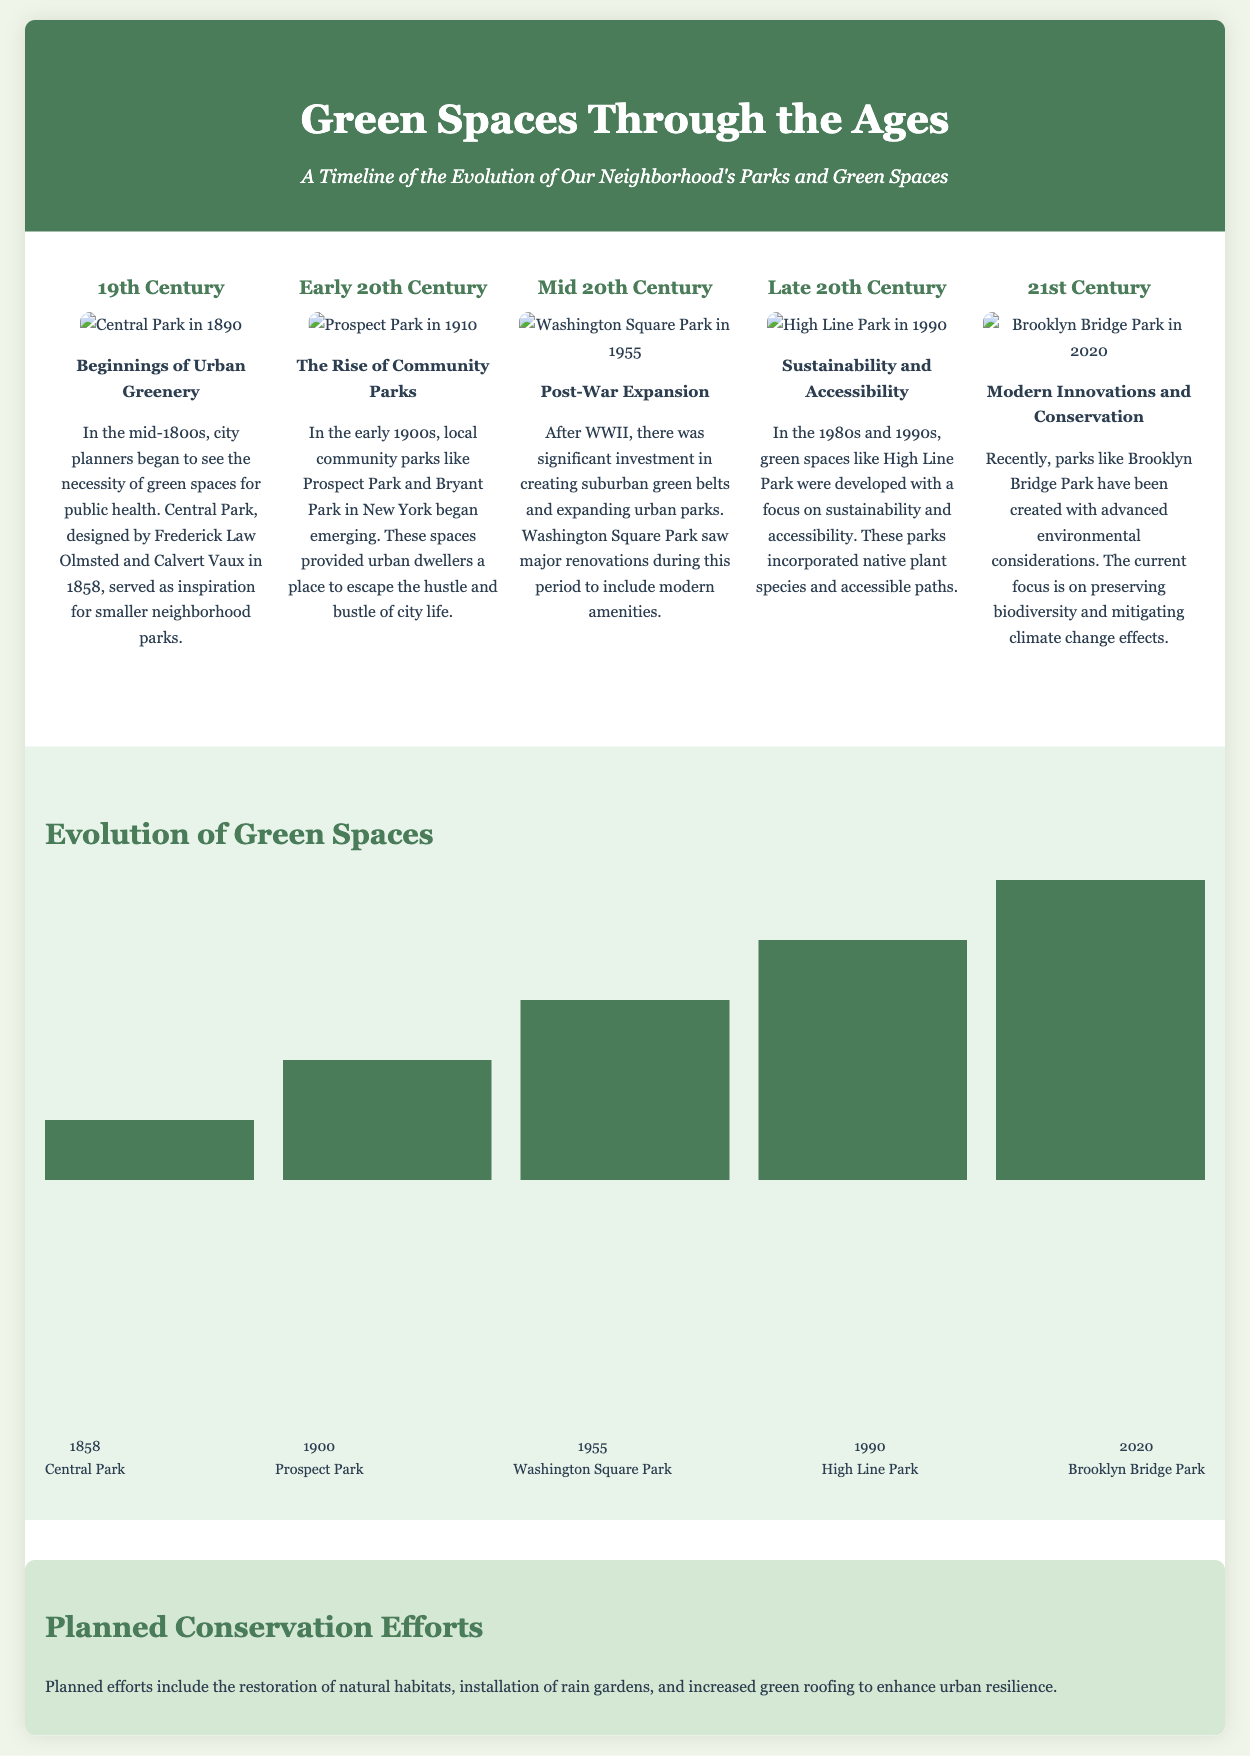What year was Central Park designed? Central Park was designed in 1858, as indicated in the timeline section.
Answer: 1858 Which park saw major renovations after WWII? The timeline mentions Washington Square Park underwent significant renovations after WWII.
Answer: Washington Square Park What is the focus of green spaces developed in the late 20th century? The document states that green spaces like High Line Park were developed focusing on sustainability and accessibility.
Answer: Sustainability and accessibility What percentage height does the graph's tallest bar reach? The tallest bar in the graph represents 100% height, which corresponds to Brooklyn Bridge Park in 2020.
Answer: 100% What type of planned conservation efforts are mentioned? The document lists restoration of natural habitats, installation of rain gardens, and green roofing as planned efforts.
Answer: Restoration of natural habitats Which period did community parks begin to emerge? The timeline indicates that community parks began emerging in the early 20th century.
Answer: Early 20th Century What was the period for post-war expansion in urban parks? The timeline states that the mid-20th century was when significant investment in suburban green belts occurred.
Answer: Mid 20th Century What is the title of the document? The title of the document, as seen in the header, is "Green Spaces Through the Ages".
Answer: Green Spaces Through the Ages 